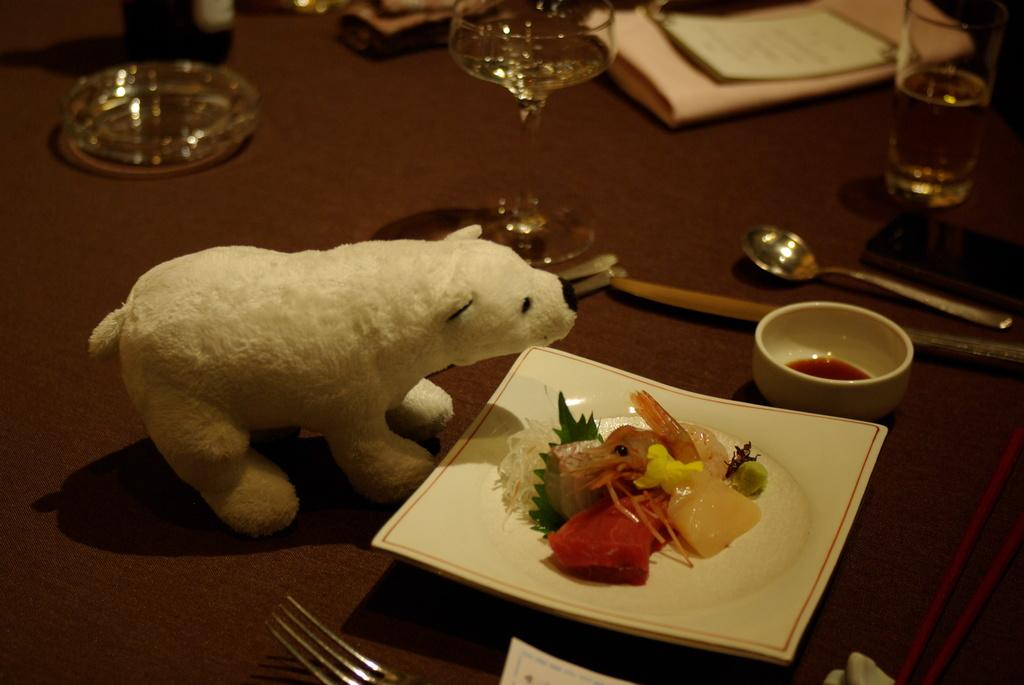What type of furniture is in the image? There is a table in the image. What is on top of the table? Food is placed on a plate on the table, cups, spoons, glasses, and papers are also present. What might be used for eating the food on the plate? Spoons are visible on the table. What is in front of the plate on the table? There is a toy in front of the plate. What country is depicted on the leaf in the image? There is no leaf present in the image. How many cents are visible on the table in the image? There is no mention of any currency or coins in the image. 